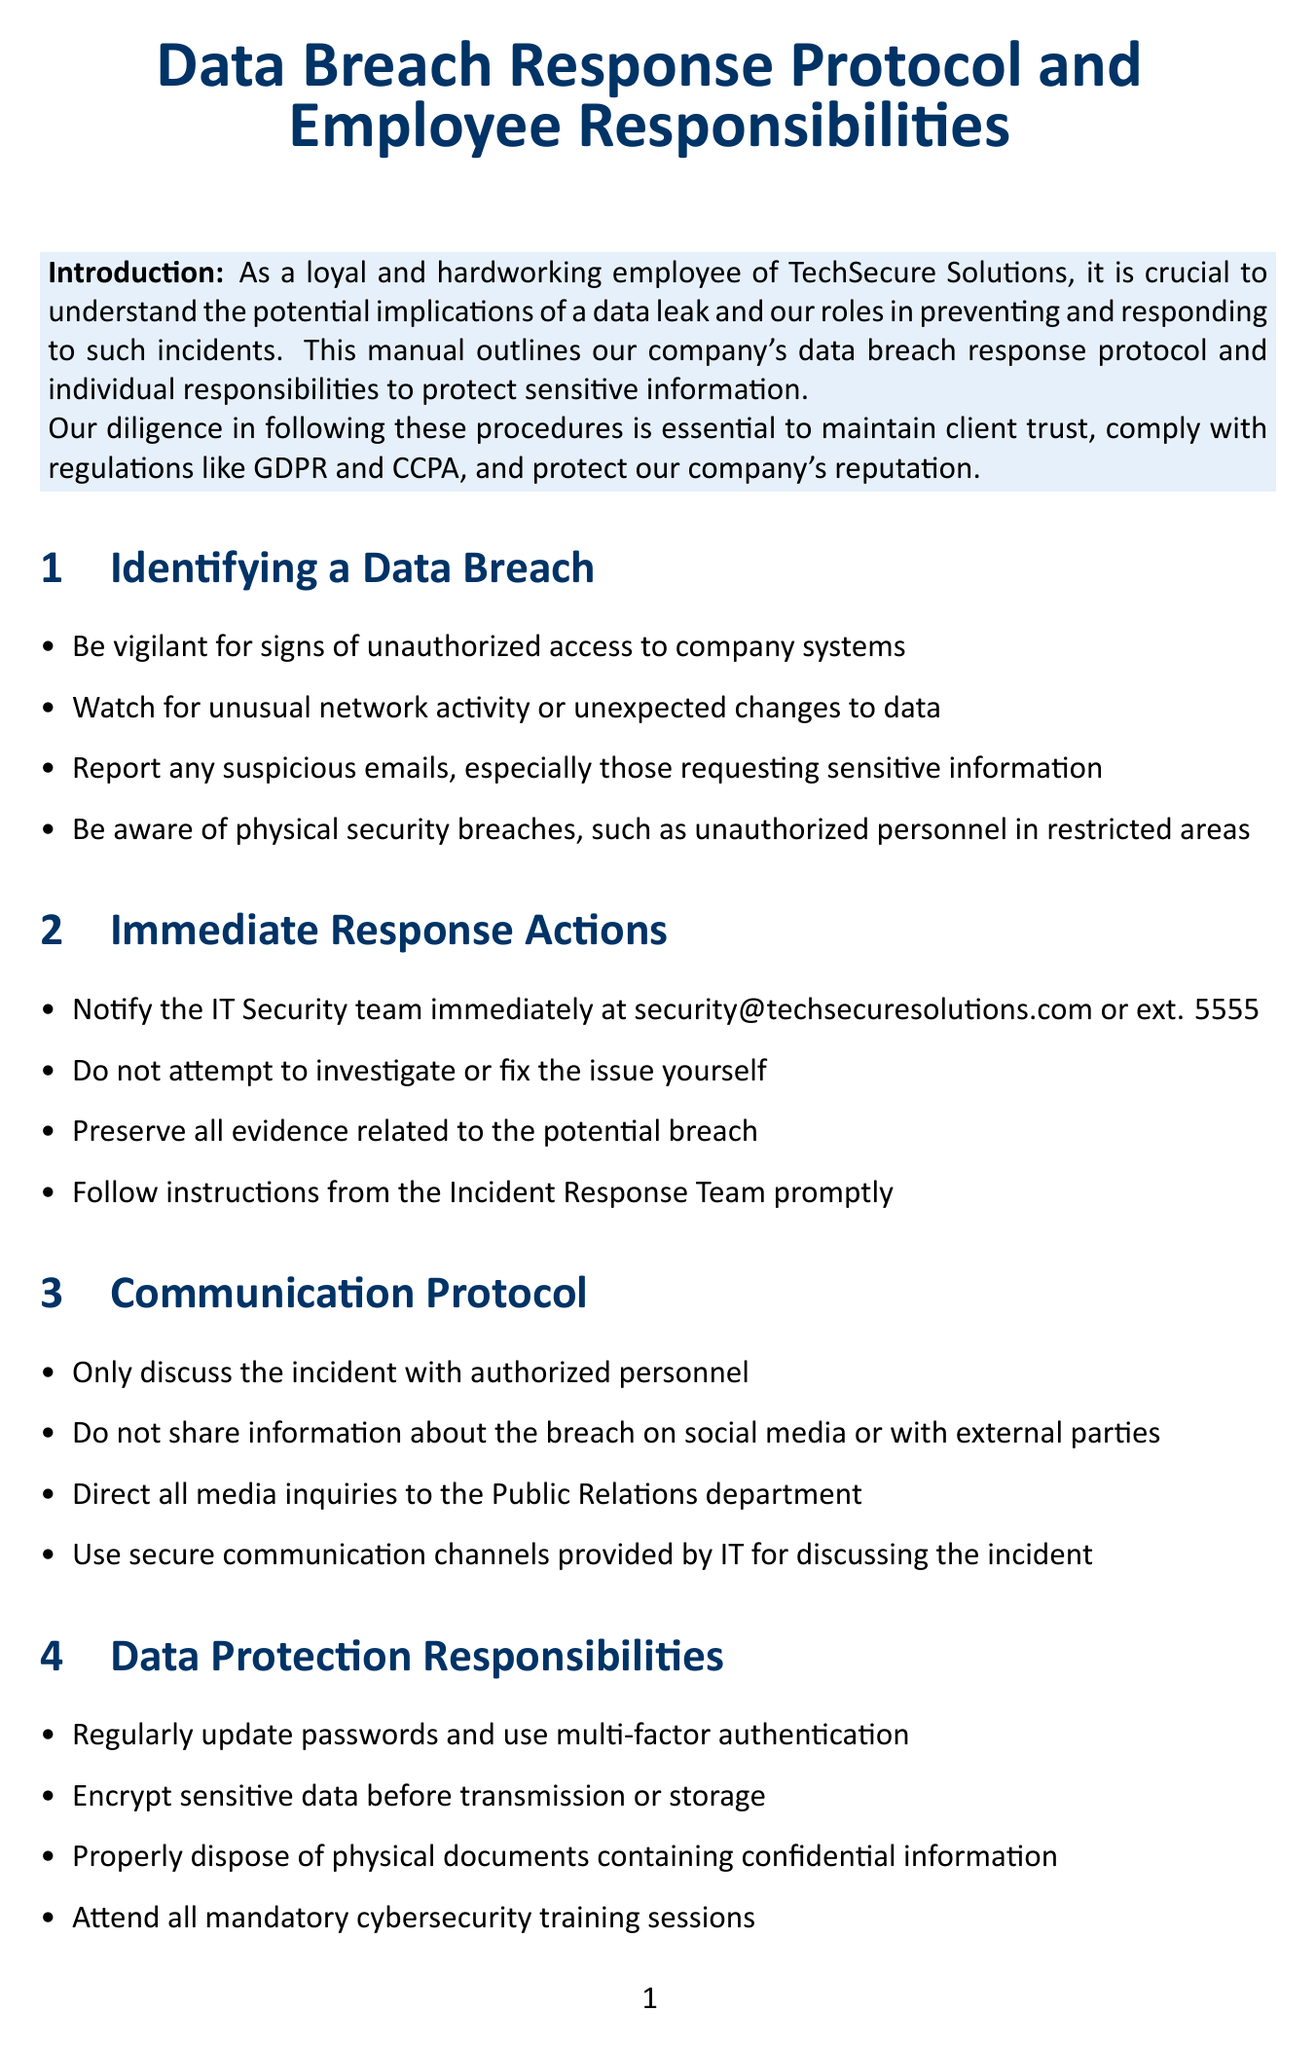what is the title of the manual? The title of the manual is explicitly mentioned in the document's introduction.
Answer: Data Breach Response Protocol and Employee Responsibilities who should you notify in case of a data breach? The manual specifies that the IT Security team should be notified immediately.
Answer: IT Security team what email address should be used to contact the IT Security team? The email address for contacting the IT Security team is provided in the immediate response actions section.
Answer: security@techsecuresolutions.com what is the first step to take when identifying a data breach? The manual outlines multiple signs to look for when identifying a data breach.
Answer: Be vigilant for signs of unauthorized access to company systems what is the consequence of failing to report a suspected data breach? The manual contains a compliance reminder related to the consequences of not reporting breaches.
Answer: disciplinary action what is the recommended action for discussing the incident? The manual provides communication protocol guidelines for discussing incidents.
Answer: Only discuss the incident with authorized personnel where can employees find additional resources related to data protection? The manual includes a section for additional resources with links to relevant sites.
Answer: TechSecure Solutions Cybersecurity Portal who is the Chief Information Security Officer? The manual lists key contacts, including their roles and contact information.
Answer: Sarah Chen how often are security audits conducted? The manual states the frequency of security audits under compliance reminders.
Answer: Regularly 